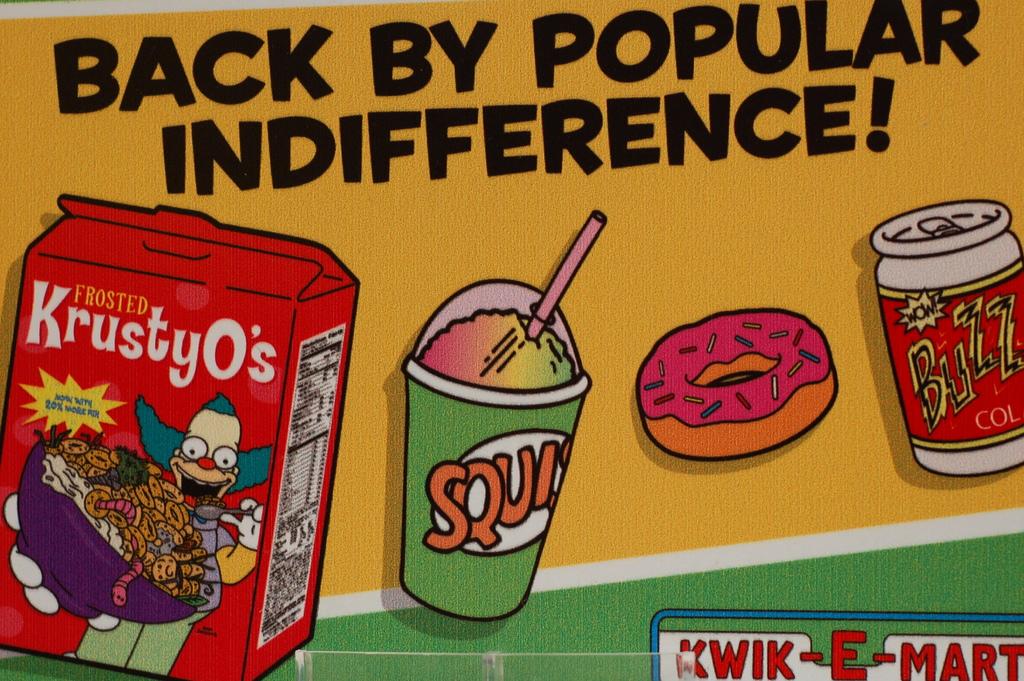What is the name of the mart in this ad?
Keep it short and to the point. Kwik-e-mart. What is the cereal name?
Give a very brief answer. Frosted krustyo's. 